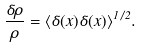Convert formula to latex. <formula><loc_0><loc_0><loc_500><loc_500>\frac { \delta \rho } { \rho } = \langle \delta ( { x } ) \delta ( { x } ) \rangle ^ { 1 / 2 } .</formula> 